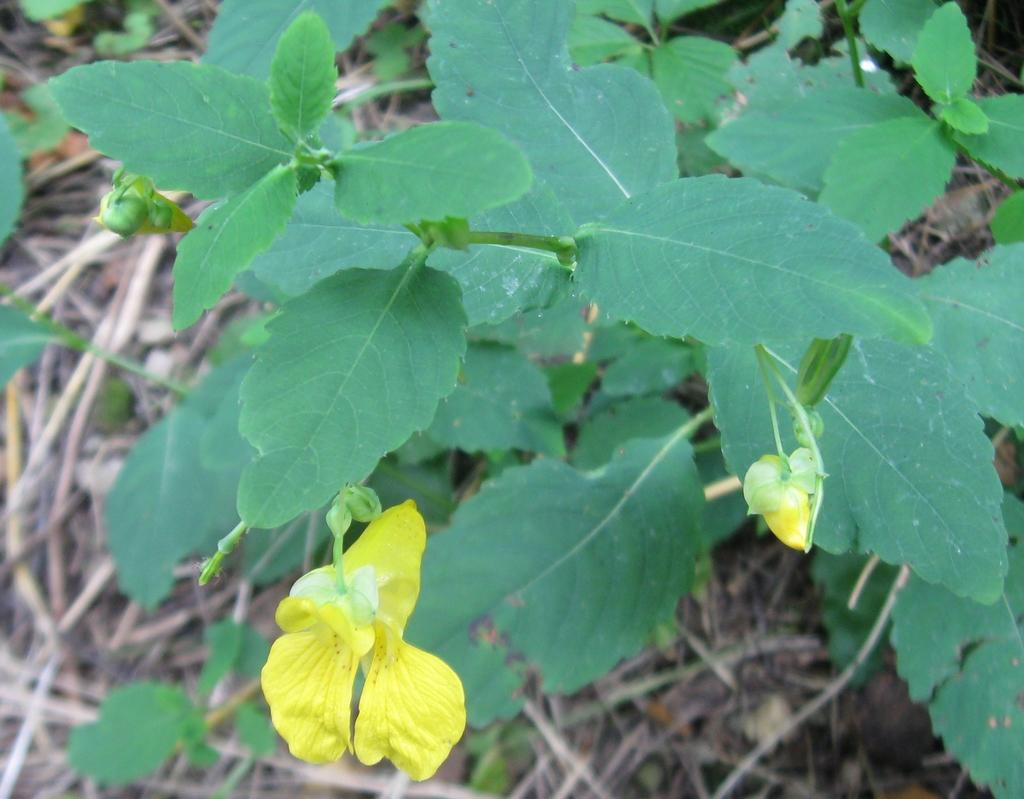What type of plants are in the image? The image contains flowers. What color are the leaves of the flowers? The flowers have green leaves. What is the texture of the ground in the image? There is dry grass at the bottom of the image. What type of destruction can be seen in the image? There is no destruction present in the image; it features flowers with green leaves and dry grass. How many potatoes are visible in the image? There are no potatoes present in the image. 